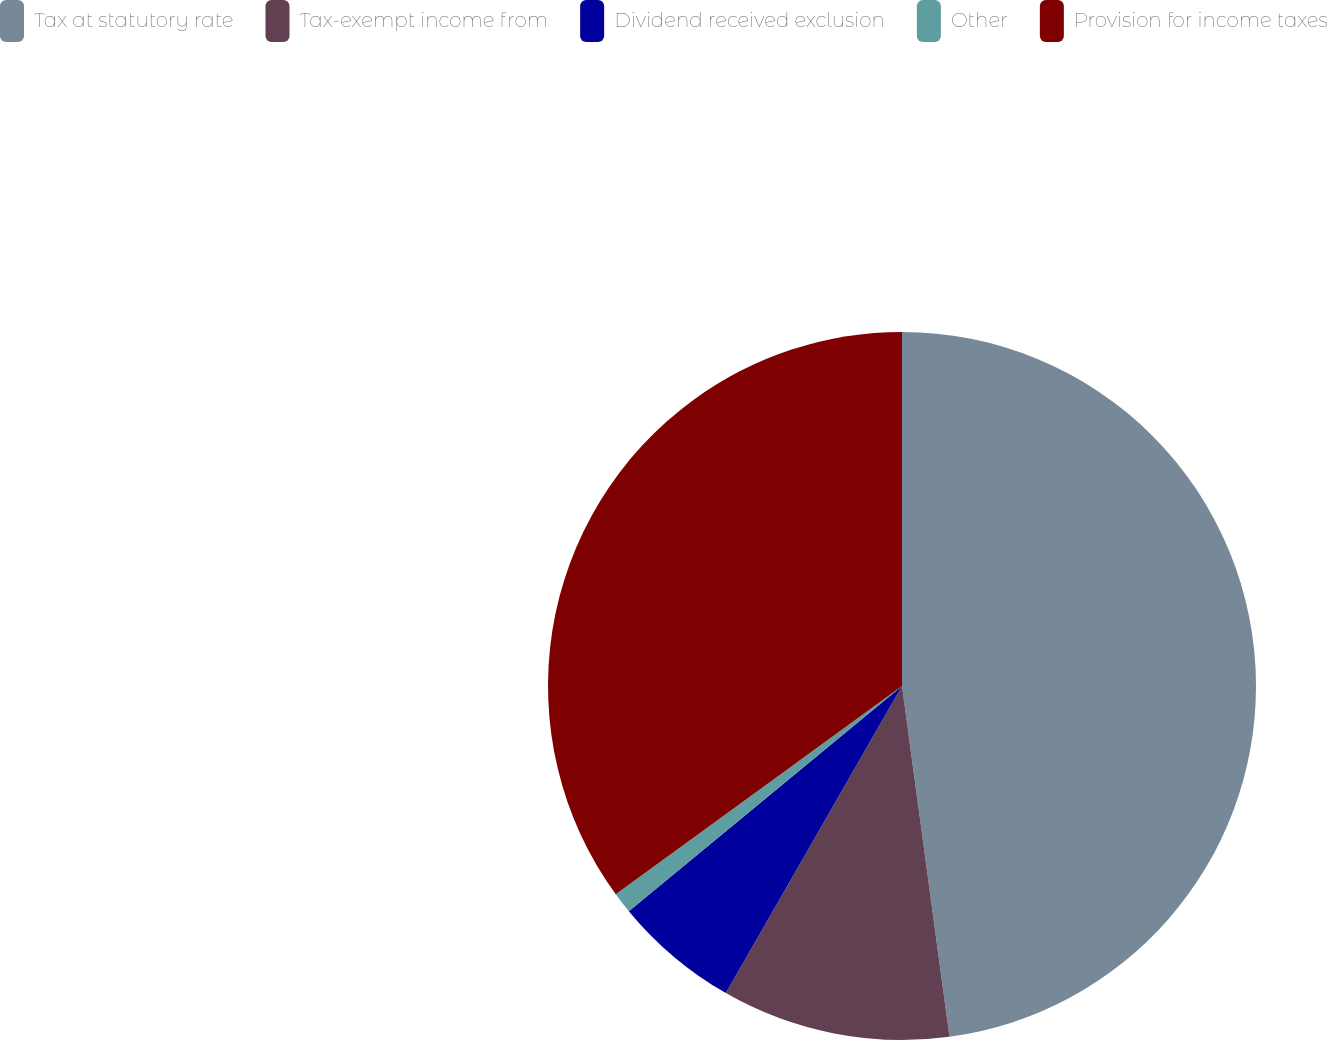Convert chart to OTSL. <chart><loc_0><loc_0><loc_500><loc_500><pie_chart><fcel>Tax at statutory rate<fcel>Tax-exempt income from<fcel>Dividend received exclusion<fcel>Other<fcel>Provision for income taxes<nl><fcel>47.86%<fcel>10.43%<fcel>5.74%<fcel>0.96%<fcel>35.01%<nl></chart> 